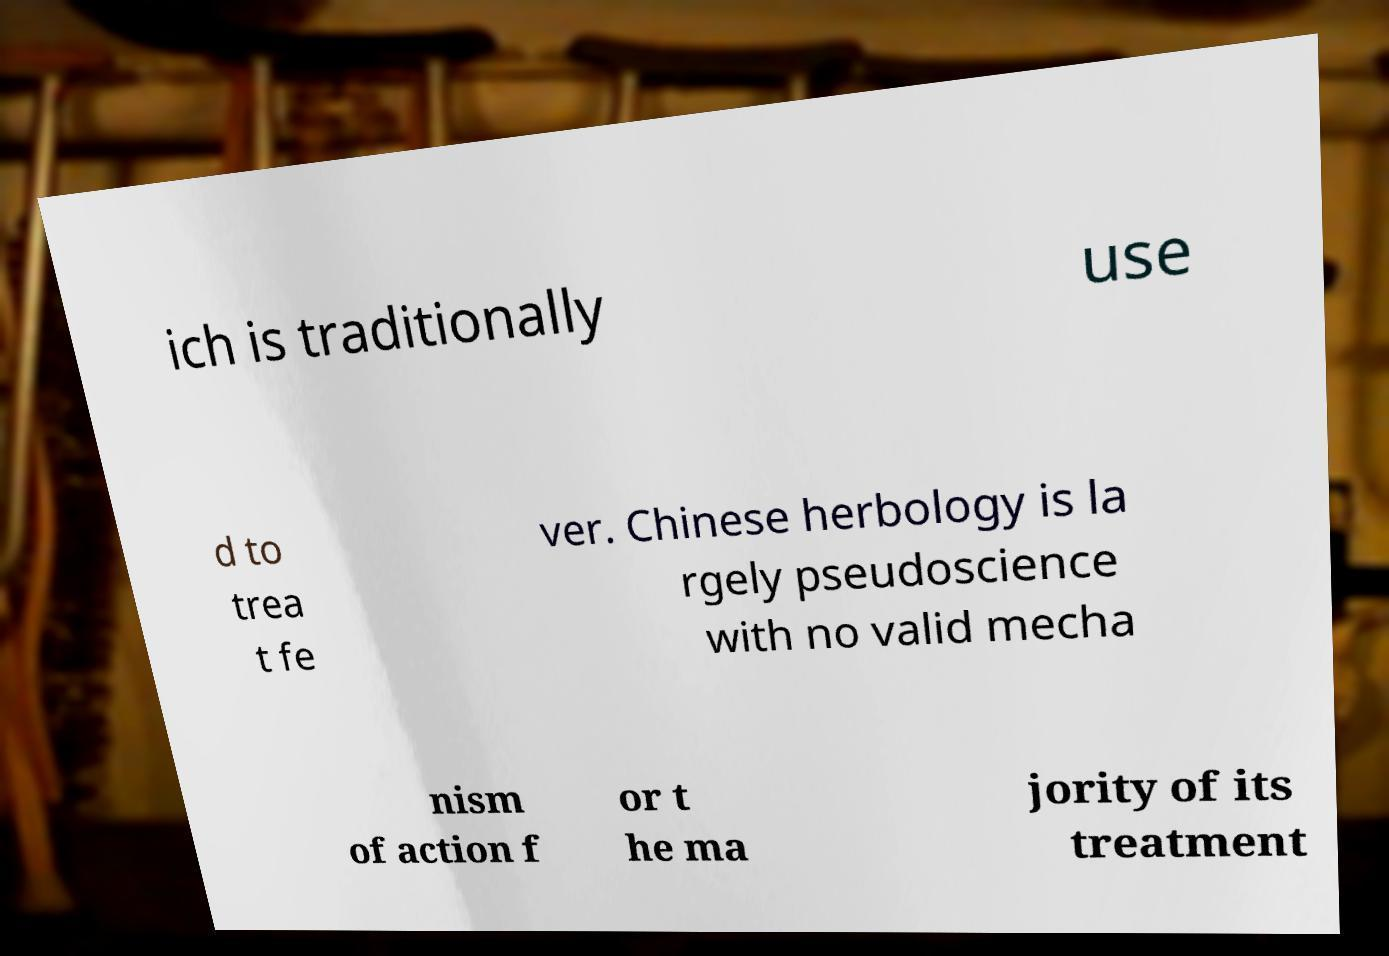I need the written content from this picture converted into text. Can you do that? ich is traditionally use d to trea t fe ver. Chinese herbology is la rgely pseudoscience with no valid mecha nism of action f or t he ma jority of its treatment 